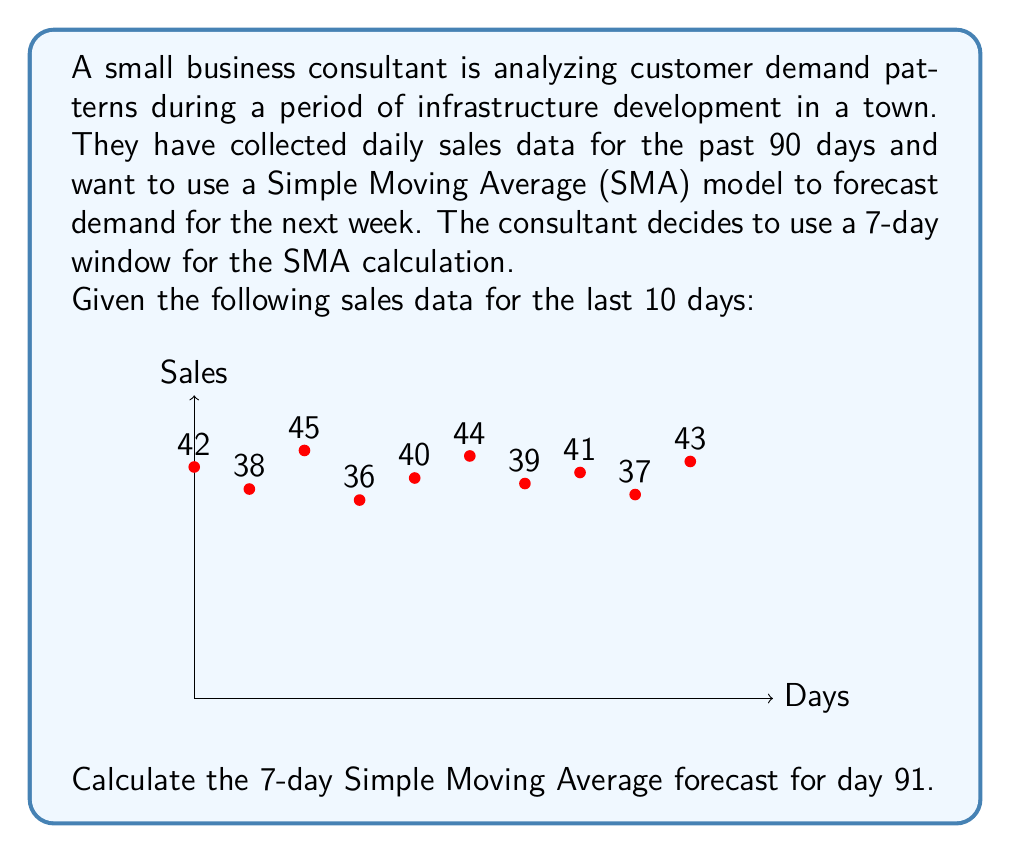Help me with this question. To solve this problem, we'll follow these steps:

1) Recall the formula for Simple Moving Average (SMA):

   $$ SMA_t = \frac{1}{n} \sum_{i=t-n+1}^t y_i $$

   Where $n$ is the window size, $t$ is the current time period, and $y_i$ are the observed values.

2) In this case, $n = 7$ (7-day window), and we want to forecast for $t = 91$.

3) To calculate the SMA for day 91, we need the sales data for the 7 most recent days (days 84-90).

4) From the given data, we have the sales for the last 10 days (days 81-90). We'll use the last 7 of these:

   Days 84-90: 40, 44, 39, 41, 37, 43, 43 (the last value is repeated as we don't have data for day 90)

5) Now, let's apply the SMA formula:

   $$ SMA_{91} = \frac{40 + 44 + 39 + 41 + 37 + 43 + 43}{7} $$

6) Calculating:

   $$ SMA_{91} = \frac{287}{7} = 41 $$

Therefore, the 7-day Simple Moving Average forecast for day 91 is 41.
Answer: 41 